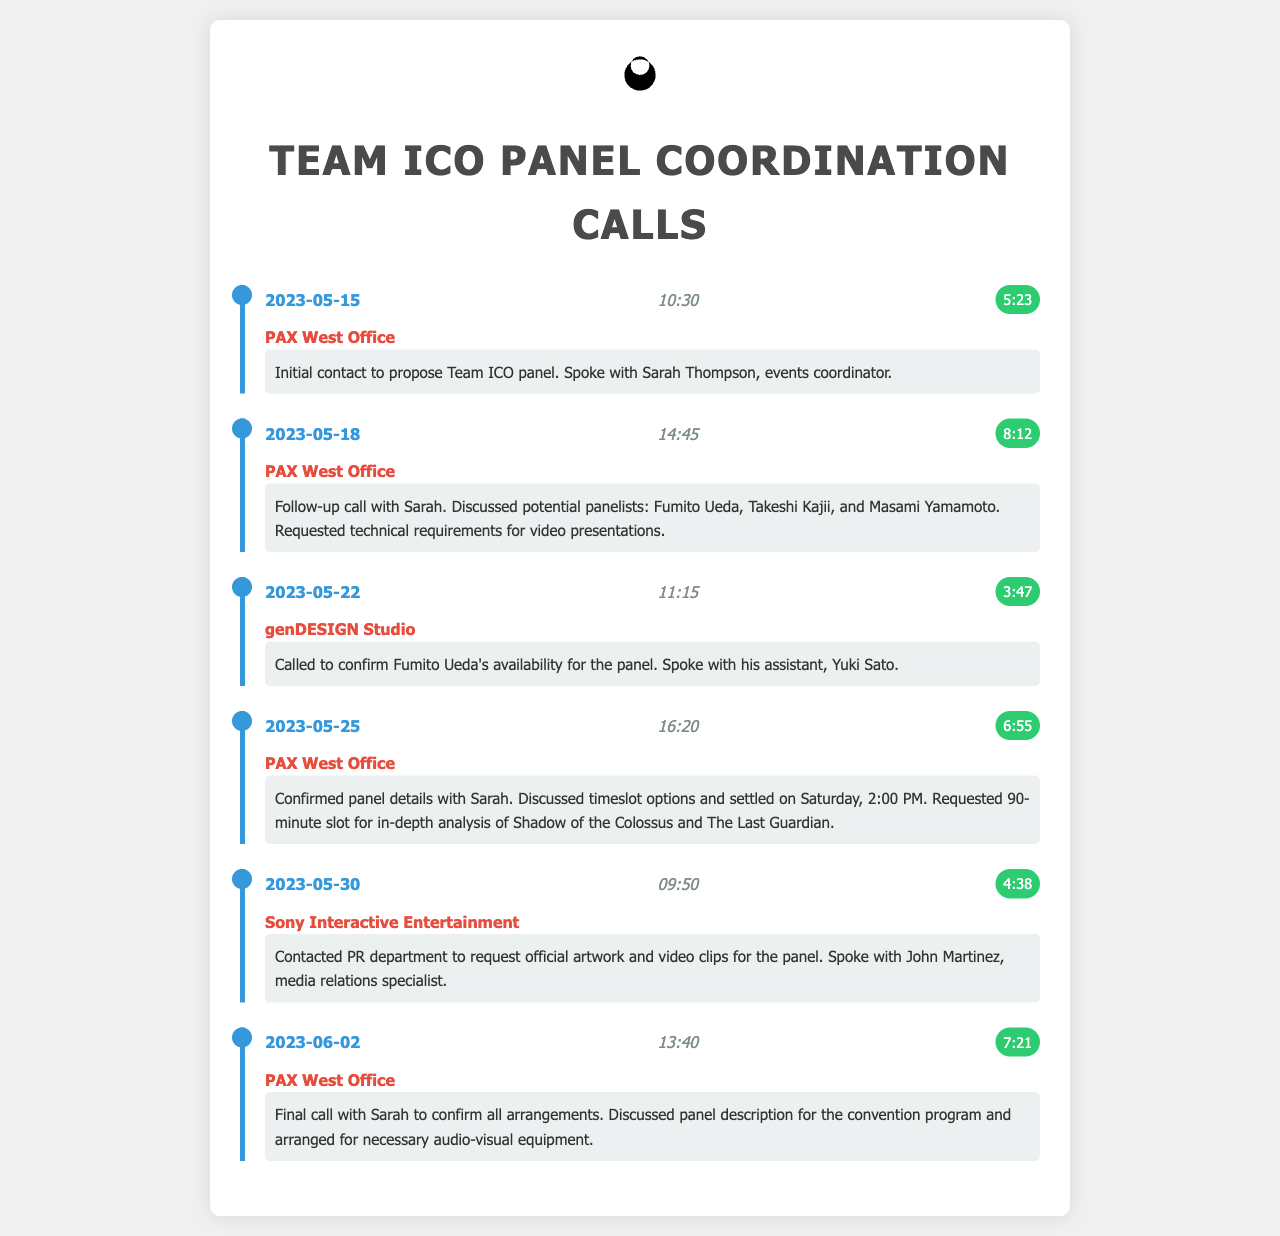What is the date of the first call? The first call is listed on the date of 2023-05-15.
Answer: 2023-05-15 Who did the caller speak with during the initial contact? The caller spoke with Sarah Thompson, an events coordinator, during the initial call.
Answer: Sarah Thompson What was discussed in the call on May 18? The call on May 18 discussed potential panelists and technical requirements for video presentations.
Answer: Panelists and technical requirements What time is the Team ICO panel scheduled for? The call on May 25 confirmed the Team ICO panel is scheduled for Saturday at 2:00 PM.
Answer: Saturday, 2:00 PM How long was the call confirming Fumito Ueda's availability? The call confirming Fumito Ueda's availability lasted 3 minutes and 47 seconds.
Answer: 3:47 What was requested from the PR department in the May 30 call? The PR department was contacted to request official artwork and video clips for the panel.
Answer: Official artwork and video clips Which date did the final call with Sarah occur? The final call with Sarah took place on June 2, as per the document structure.
Answer: 2023-06-02 How many potential panelists were mentioned in the follow-up call? The follow-up call mentioned three potential panelists for the Team ICO panel.
Answer: Three 